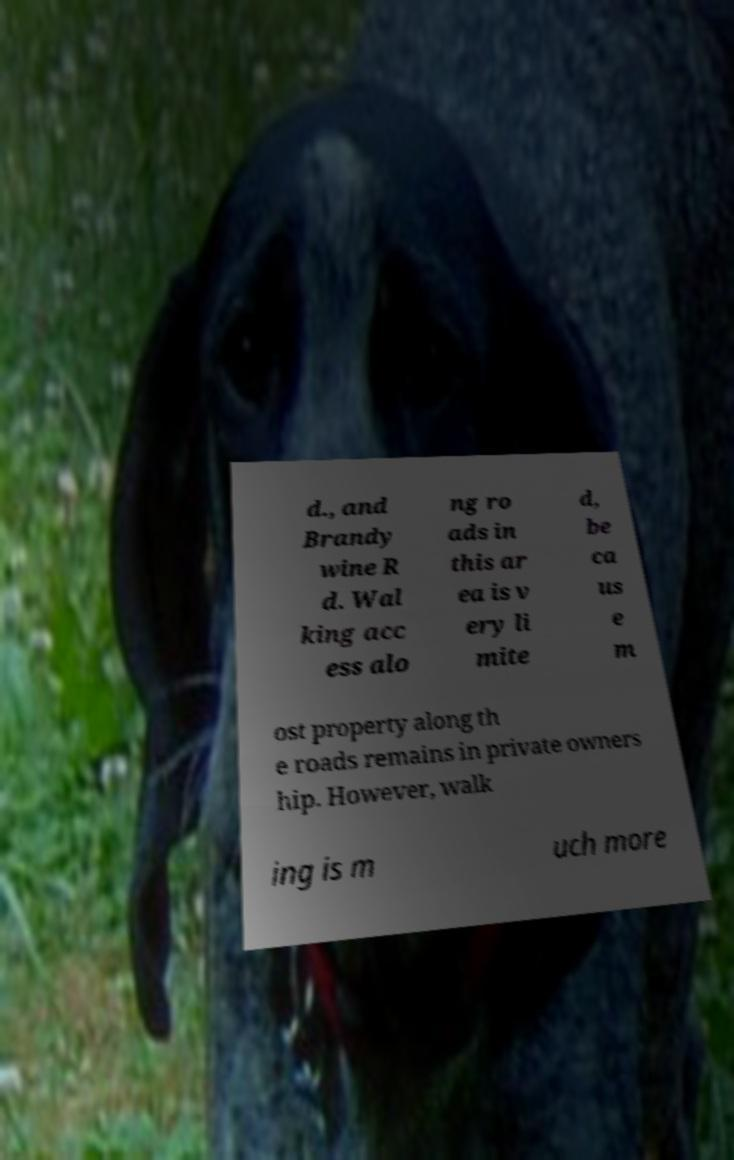I need the written content from this picture converted into text. Can you do that? d., and Brandy wine R d. Wal king acc ess alo ng ro ads in this ar ea is v ery li mite d, be ca us e m ost property along th e roads remains in private owners hip. However, walk ing is m uch more 